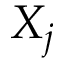Convert formula to latex. <formula><loc_0><loc_0><loc_500><loc_500>X _ { j }</formula> 